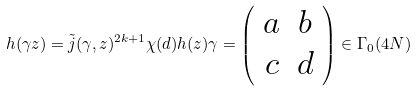Convert formula to latex. <formula><loc_0><loc_0><loc_500><loc_500>h ( \gamma z ) = \tilde { j } ( \gamma , z ) ^ { 2 k + 1 } \chi ( d ) h ( z ) \gamma = \left ( \begin{array} { c c } a & b \\ c & d \end{array} \right ) \in \Gamma _ { 0 } ( 4 N )</formula> 